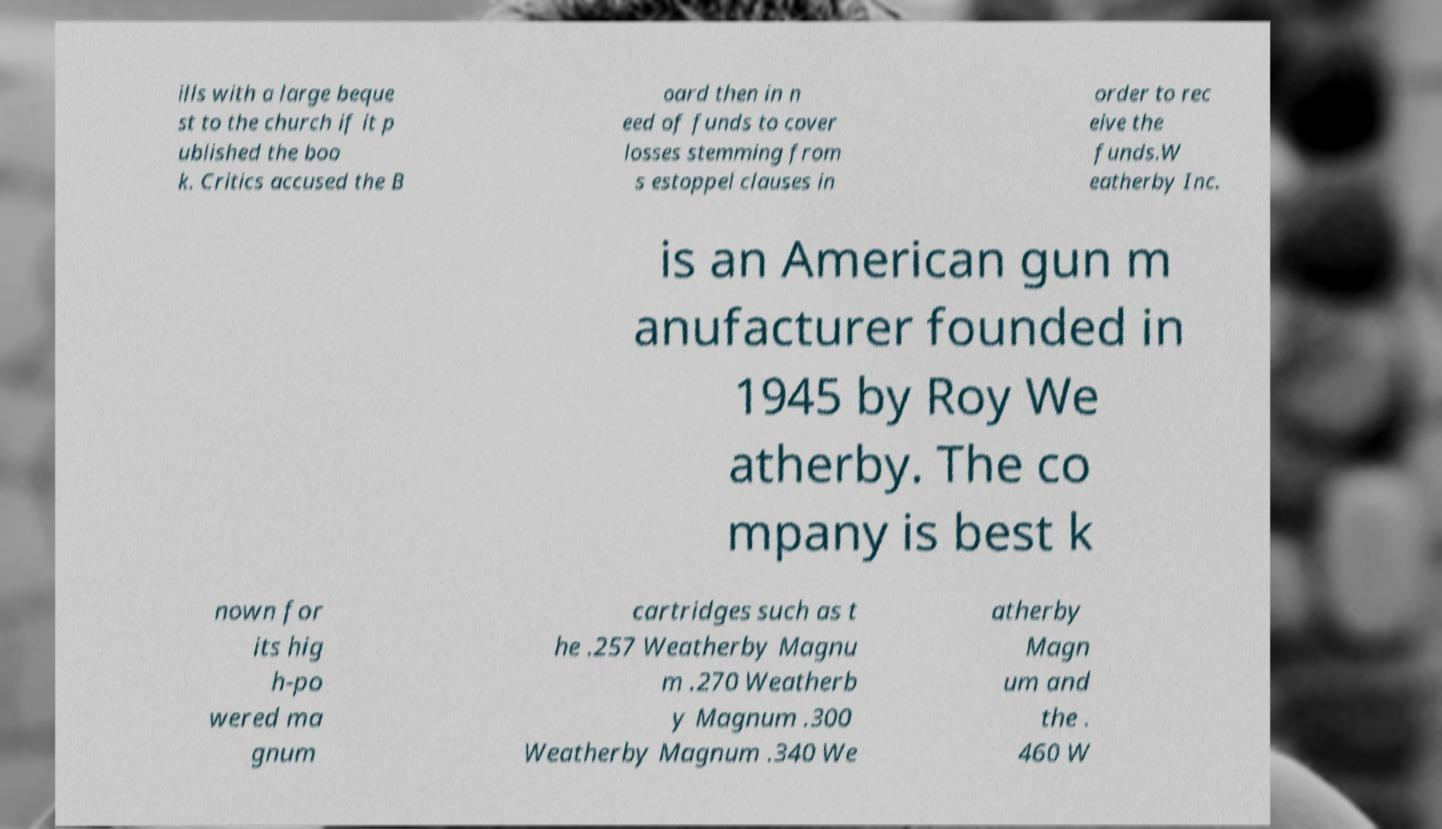What messages or text are displayed in this image? I need them in a readable, typed format. ills with a large beque st to the church if it p ublished the boo k. Critics accused the B oard then in n eed of funds to cover losses stemming from s estoppel clauses in order to rec eive the funds.W eatherby Inc. is an American gun m anufacturer founded in 1945 by Roy We atherby. The co mpany is best k nown for its hig h-po wered ma gnum cartridges such as t he .257 Weatherby Magnu m .270 Weatherb y Magnum .300 Weatherby Magnum .340 We atherby Magn um and the . 460 W 